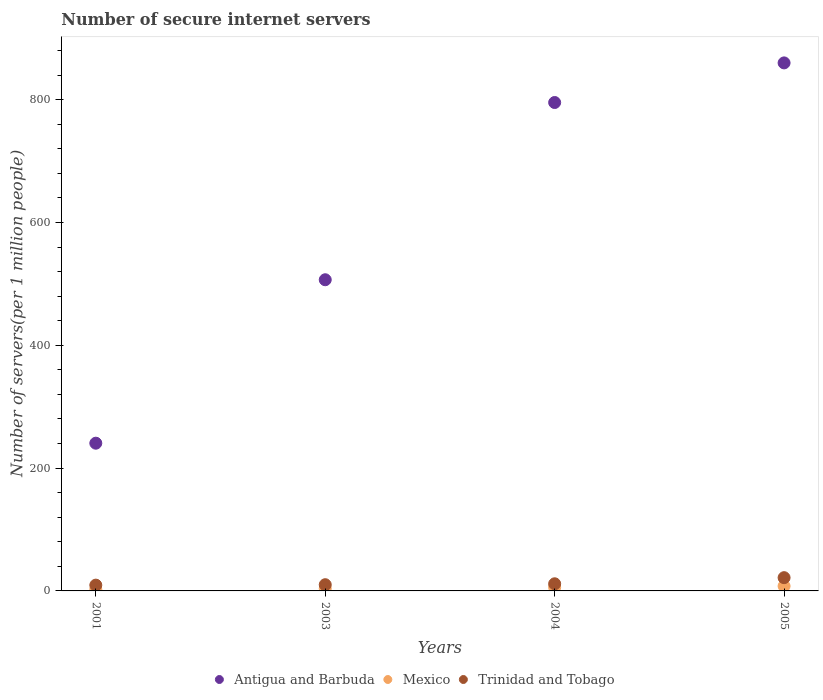Is the number of dotlines equal to the number of legend labels?
Provide a succinct answer. Yes. What is the number of secure internet servers in Trinidad and Tobago in 2005?
Provide a succinct answer. 21.59. Across all years, what is the maximum number of secure internet servers in Antigua and Barbuda?
Your response must be concise. 859.93. Across all years, what is the minimum number of secure internet servers in Mexico?
Ensure brevity in your answer.  2.48. In which year was the number of secure internet servers in Trinidad and Tobago minimum?
Your response must be concise. 2001. What is the total number of secure internet servers in Trinidad and Tobago in the graph?
Provide a short and direct response. 52.77. What is the difference between the number of secure internet servers in Trinidad and Tobago in 2004 and that in 2005?
Offer a terse response. -9.97. What is the difference between the number of secure internet servers in Trinidad and Tobago in 2004 and the number of secure internet servers in Mexico in 2001?
Offer a terse response. 9.14. What is the average number of secure internet servers in Trinidad and Tobago per year?
Offer a very short reply. 13.19. In the year 2005, what is the difference between the number of secure internet servers in Mexico and number of secure internet servers in Antigua and Barbuda?
Your response must be concise. -852.07. In how many years, is the number of secure internet servers in Antigua and Barbuda greater than 40?
Ensure brevity in your answer.  4. What is the ratio of the number of secure internet servers in Antigua and Barbuda in 2003 to that in 2004?
Provide a short and direct response. 0.64. Is the number of secure internet servers in Antigua and Barbuda in 2001 less than that in 2004?
Keep it short and to the point. Yes. Is the difference between the number of secure internet servers in Mexico in 2001 and 2003 greater than the difference between the number of secure internet servers in Antigua and Barbuda in 2001 and 2003?
Make the answer very short. Yes. What is the difference between the highest and the second highest number of secure internet servers in Antigua and Barbuda?
Offer a terse response. 64.51. What is the difference between the highest and the lowest number of secure internet servers in Trinidad and Tobago?
Your response must be concise. 12.16. Is the number of secure internet servers in Trinidad and Tobago strictly less than the number of secure internet servers in Mexico over the years?
Offer a terse response. No. How many years are there in the graph?
Give a very brief answer. 4. What is the difference between two consecutive major ticks on the Y-axis?
Ensure brevity in your answer.  200. Are the values on the major ticks of Y-axis written in scientific E-notation?
Keep it short and to the point. No. Does the graph contain any zero values?
Make the answer very short. No. Does the graph contain grids?
Your answer should be very brief. No. Where does the legend appear in the graph?
Make the answer very short. Bottom center. How are the legend labels stacked?
Your answer should be compact. Horizontal. What is the title of the graph?
Provide a short and direct response. Number of secure internet servers. What is the label or title of the X-axis?
Your answer should be compact. Years. What is the label or title of the Y-axis?
Your answer should be very brief. Number of servers(per 1 million people). What is the Number of servers(per 1 million people) of Antigua and Barbuda in 2001?
Offer a terse response. 240.59. What is the Number of servers(per 1 million people) of Mexico in 2001?
Offer a very short reply. 2.48. What is the Number of servers(per 1 million people) of Trinidad and Tobago in 2001?
Make the answer very short. 9.43. What is the Number of servers(per 1 million people) of Antigua and Barbuda in 2003?
Give a very brief answer. 506.77. What is the Number of servers(per 1 million people) in Mexico in 2003?
Keep it short and to the point. 3.89. What is the Number of servers(per 1 million people) in Trinidad and Tobago in 2003?
Give a very brief answer. 10.12. What is the Number of servers(per 1 million people) in Antigua and Barbuda in 2004?
Your answer should be very brief. 795.42. What is the Number of servers(per 1 million people) in Mexico in 2004?
Your answer should be compact. 5.86. What is the Number of servers(per 1 million people) in Trinidad and Tobago in 2004?
Keep it short and to the point. 11.62. What is the Number of servers(per 1 million people) in Antigua and Barbuda in 2005?
Provide a succinct answer. 859.93. What is the Number of servers(per 1 million people) in Mexico in 2005?
Keep it short and to the point. 7.86. What is the Number of servers(per 1 million people) in Trinidad and Tobago in 2005?
Offer a very short reply. 21.59. Across all years, what is the maximum Number of servers(per 1 million people) of Antigua and Barbuda?
Keep it short and to the point. 859.93. Across all years, what is the maximum Number of servers(per 1 million people) of Mexico?
Offer a terse response. 7.86. Across all years, what is the maximum Number of servers(per 1 million people) in Trinidad and Tobago?
Provide a short and direct response. 21.59. Across all years, what is the minimum Number of servers(per 1 million people) of Antigua and Barbuda?
Offer a terse response. 240.59. Across all years, what is the minimum Number of servers(per 1 million people) in Mexico?
Your answer should be very brief. 2.48. Across all years, what is the minimum Number of servers(per 1 million people) of Trinidad and Tobago?
Your response must be concise. 9.43. What is the total Number of servers(per 1 million people) of Antigua and Barbuda in the graph?
Make the answer very short. 2402.71. What is the total Number of servers(per 1 million people) in Mexico in the graph?
Offer a very short reply. 20.1. What is the total Number of servers(per 1 million people) of Trinidad and Tobago in the graph?
Offer a very short reply. 52.77. What is the difference between the Number of servers(per 1 million people) of Antigua and Barbuda in 2001 and that in 2003?
Your answer should be compact. -266.18. What is the difference between the Number of servers(per 1 million people) in Mexico in 2001 and that in 2003?
Your response must be concise. -1.41. What is the difference between the Number of servers(per 1 million people) of Trinidad and Tobago in 2001 and that in 2003?
Make the answer very short. -0.69. What is the difference between the Number of servers(per 1 million people) of Antigua and Barbuda in 2001 and that in 2004?
Offer a terse response. -554.83. What is the difference between the Number of servers(per 1 million people) of Mexico in 2001 and that in 2004?
Offer a very short reply. -3.37. What is the difference between the Number of servers(per 1 million people) of Trinidad and Tobago in 2001 and that in 2004?
Your answer should be very brief. -2.19. What is the difference between the Number of servers(per 1 million people) in Antigua and Barbuda in 2001 and that in 2005?
Offer a very short reply. -619.34. What is the difference between the Number of servers(per 1 million people) of Mexico in 2001 and that in 2005?
Make the answer very short. -5.38. What is the difference between the Number of servers(per 1 million people) in Trinidad and Tobago in 2001 and that in 2005?
Give a very brief answer. -12.16. What is the difference between the Number of servers(per 1 million people) of Antigua and Barbuda in 2003 and that in 2004?
Your answer should be very brief. -288.64. What is the difference between the Number of servers(per 1 million people) in Mexico in 2003 and that in 2004?
Offer a terse response. -1.96. What is the difference between the Number of servers(per 1 million people) in Trinidad and Tobago in 2003 and that in 2004?
Your answer should be compact. -1.5. What is the difference between the Number of servers(per 1 million people) of Antigua and Barbuda in 2003 and that in 2005?
Make the answer very short. -353.16. What is the difference between the Number of servers(per 1 million people) in Mexico in 2003 and that in 2005?
Your answer should be compact. -3.97. What is the difference between the Number of servers(per 1 million people) of Trinidad and Tobago in 2003 and that in 2005?
Your answer should be compact. -11.47. What is the difference between the Number of servers(per 1 million people) in Antigua and Barbuda in 2004 and that in 2005?
Make the answer very short. -64.51. What is the difference between the Number of servers(per 1 million people) in Mexico in 2004 and that in 2005?
Your answer should be compact. -2.01. What is the difference between the Number of servers(per 1 million people) in Trinidad and Tobago in 2004 and that in 2005?
Ensure brevity in your answer.  -9.97. What is the difference between the Number of servers(per 1 million people) in Antigua and Barbuda in 2001 and the Number of servers(per 1 million people) in Mexico in 2003?
Provide a succinct answer. 236.7. What is the difference between the Number of servers(per 1 million people) of Antigua and Barbuda in 2001 and the Number of servers(per 1 million people) of Trinidad and Tobago in 2003?
Your answer should be compact. 230.47. What is the difference between the Number of servers(per 1 million people) in Mexico in 2001 and the Number of servers(per 1 million people) in Trinidad and Tobago in 2003?
Offer a very short reply. -7.64. What is the difference between the Number of servers(per 1 million people) in Antigua and Barbuda in 2001 and the Number of servers(per 1 million people) in Mexico in 2004?
Offer a terse response. 234.74. What is the difference between the Number of servers(per 1 million people) in Antigua and Barbuda in 2001 and the Number of servers(per 1 million people) in Trinidad and Tobago in 2004?
Ensure brevity in your answer.  228.97. What is the difference between the Number of servers(per 1 million people) in Mexico in 2001 and the Number of servers(per 1 million people) in Trinidad and Tobago in 2004?
Your answer should be compact. -9.14. What is the difference between the Number of servers(per 1 million people) in Antigua and Barbuda in 2001 and the Number of servers(per 1 million people) in Mexico in 2005?
Make the answer very short. 232.73. What is the difference between the Number of servers(per 1 million people) in Antigua and Barbuda in 2001 and the Number of servers(per 1 million people) in Trinidad and Tobago in 2005?
Your answer should be compact. 219. What is the difference between the Number of servers(per 1 million people) in Mexico in 2001 and the Number of servers(per 1 million people) in Trinidad and Tobago in 2005?
Provide a succinct answer. -19.1. What is the difference between the Number of servers(per 1 million people) of Antigua and Barbuda in 2003 and the Number of servers(per 1 million people) of Mexico in 2004?
Your response must be concise. 500.92. What is the difference between the Number of servers(per 1 million people) in Antigua and Barbuda in 2003 and the Number of servers(per 1 million people) in Trinidad and Tobago in 2004?
Provide a succinct answer. 495.15. What is the difference between the Number of servers(per 1 million people) in Mexico in 2003 and the Number of servers(per 1 million people) in Trinidad and Tobago in 2004?
Ensure brevity in your answer.  -7.73. What is the difference between the Number of servers(per 1 million people) of Antigua and Barbuda in 2003 and the Number of servers(per 1 million people) of Mexico in 2005?
Ensure brevity in your answer.  498.91. What is the difference between the Number of servers(per 1 million people) of Antigua and Barbuda in 2003 and the Number of servers(per 1 million people) of Trinidad and Tobago in 2005?
Offer a very short reply. 485.18. What is the difference between the Number of servers(per 1 million people) in Mexico in 2003 and the Number of servers(per 1 million people) in Trinidad and Tobago in 2005?
Offer a terse response. -17.7. What is the difference between the Number of servers(per 1 million people) of Antigua and Barbuda in 2004 and the Number of servers(per 1 million people) of Mexico in 2005?
Make the answer very short. 787.55. What is the difference between the Number of servers(per 1 million people) of Antigua and Barbuda in 2004 and the Number of servers(per 1 million people) of Trinidad and Tobago in 2005?
Offer a terse response. 773.83. What is the difference between the Number of servers(per 1 million people) of Mexico in 2004 and the Number of servers(per 1 million people) of Trinidad and Tobago in 2005?
Your answer should be compact. -15.73. What is the average Number of servers(per 1 million people) of Antigua and Barbuda per year?
Offer a very short reply. 600.68. What is the average Number of servers(per 1 million people) of Mexico per year?
Provide a succinct answer. 5.02. What is the average Number of servers(per 1 million people) of Trinidad and Tobago per year?
Make the answer very short. 13.19. In the year 2001, what is the difference between the Number of servers(per 1 million people) of Antigua and Barbuda and Number of servers(per 1 million people) of Mexico?
Make the answer very short. 238.11. In the year 2001, what is the difference between the Number of servers(per 1 million people) of Antigua and Barbuda and Number of servers(per 1 million people) of Trinidad and Tobago?
Offer a terse response. 231.16. In the year 2001, what is the difference between the Number of servers(per 1 million people) of Mexico and Number of servers(per 1 million people) of Trinidad and Tobago?
Ensure brevity in your answer.  -6.95. In the year 2003, what is the difference between the Number of servers(per 1 million people) of Antigua and Barbuda and Number of servers(per 1 million people) of Mexico?
Ensure brevity in your answer.  502.88. In the year 2003, what is the difference between the Number of servers(per 1 million people) of Antigua and Barbuda and Number of servers(per 1 million people) of Trinidad and Tobago?
Provide a short and direct response. 496.65. In the year 2003, what is the difference between the Number of servers(per 1 million people) in Mexico and Number of servers(per 1 million people) in Trinidad and Tobago?
Provide a short and direct response. -6.23. In the year 2004, what is the difference between the Number of servers(per 1 million people) of Antigua and Barbuda and Number of servers(per 1 million people) of Mexico?
Your answer should be very brief. 789.56. In the year 2004, what is the difference between the Number of servers(per 1 million people) in Antigua and Barbuda and Number of servers(per 1 million people) in Trinidad and Tobago?
Provide a short and direct response. 783.8. In the year 2004, what is the difference between the Number of servers(per 1 million people) in Mexico and Number of servers(per 1 million people) in Trinidad and Tobago?
Provide a succinct answer. -5.77. In the year 2005, what is the difference between the Number of servers(per 1 million people) of Antigua and Barbuda and Number of servers(per 1 million people) of Mexico?
Offer a terse response. 852.07. In the year 2005, what is the difference between the Number of servers(per 1 million people) in Antigua and Barbuda and Number of servers(per 1 million people) in Trinidad and Tobago?
Your response must be concise. 838.34. In the year 2005, what is the difference between the Number of servers(per 1 million people) of Mexico and Number of servers(per 1 million people) of Trinidad and Tobago?
Offer a terse response. -13.73. What is the ratio of the Number of servers(per 1 million people) in Antigua and Barbuda in 2001 to that in 2003?
Provide a short and direct response. 0.47. What is the ratio of the Number of servers(per 1 million people) of Mexico in 2001 to that in 2003?
Offer a very short reply. 0.64. What is the ratio of the Number of servers(per 1 million people) in Trinidad and Tobago in 2001 to that in 2003?
Your answer should be very brief. 0.93. What is the ratio of the Number of servers(per 1 million people) of Antigua and Barbuda in 2001 to that in 2004?
Ensure brevity in your answer.  0.3. What is the ratio of the Number of servers(per 1 million people) in Mexico in 2001 to that in 2004?
Keep it short and to the point. 0.42. What is the ratio of the Number of servers(per 1 million people) of Trinidad and Tobago in 2001 to that in 2004?
Your answer should be compact. 0.81. What is the ratio of the Number of servers(per 1 million people) of Antigua and Barbuda in 2001 to that in 2005?
Offer a very short reply. 0.28. What is the ratio of the Number of servers(per 1 million people) of Mexico in 2001 to that in 2005?
Ensure brevity in your answer.  0.32. What is the ratio of the Number of servers(per 1 million people) in Trinidad and Tobago in 2001 to that in 2005?
Give a very brief answer. 0.44. What is the ratio of the Number of servers(per 1 million people) of Antigua and Barbuda in 2003 to that in 2004?
Offer a very short reply. 0.64. What is the ratio of the Number of servers(per 1 million people) of Mexico in 2003 to that in 2004?
Your response must be concise. 0.66. What is the ratio of the Number of servers(per 1 million people) in Trinidad and Tobago in 2003 to that in 2004?
Offer a terse response. 0.87. What is the ratio of the Number of servers(per 1 million people) of Antigua and Barbuda in 2003 to that in 2005?
Give a very brief answer. 0.59. What is the ratio of the Number of servers(per 1 million people) of Mexico in 2003 to that in 2005?
Offer a terse response. 0.49. What is the ratio of the Number of servers(per 1 million people) of Trinidad and Tobago in 2003 to that in 2005?
Provide a succinct answer. 0.47. What is the ratio of the Number of servers(per 1 million people) of Antigua and Barbuda in 2004 to that in 2005?
Your response must be concise. 0.93. What is the ratio of the Number of servers(per 1 million people) in Mexico in 2004 to that in 2005?
Offer a terse response. 0.74. What is the ratio of the Number of servers(per 1 million people) of Trinidad and Tobago in 2004 to that in 2005?
Ensure brevity in your answer.  0.54. What is the difference between the highest and the second highest Number of servers(per 1 million people) of Antigua and Barbuda?
Offer a very short reply. 64.51. What is the difference between the highest and the second highest Number of servers(per 1 million people) of Mexico?
Offer a very short reply. 2.01. What is the difference between the highest and the second highest Number of servers(per 1 million people) of Trinidad and Tobago?
Your response must be concise. 9.97. What is the difference between the highest and the lowest Number of servers(per 1 million people) in Antigua and Barbuda?
Make the answer very short. 619.34. What is the difference between the highest and the lowest Number of servers(per 1 million people) in Mexico?
Ensure brevity in your answer.  5.38. What is the difference between the highest and the lowest Number of servers(per 1 million people) of Trinidad and Tobago?
Make the answer very short. 12.16. 